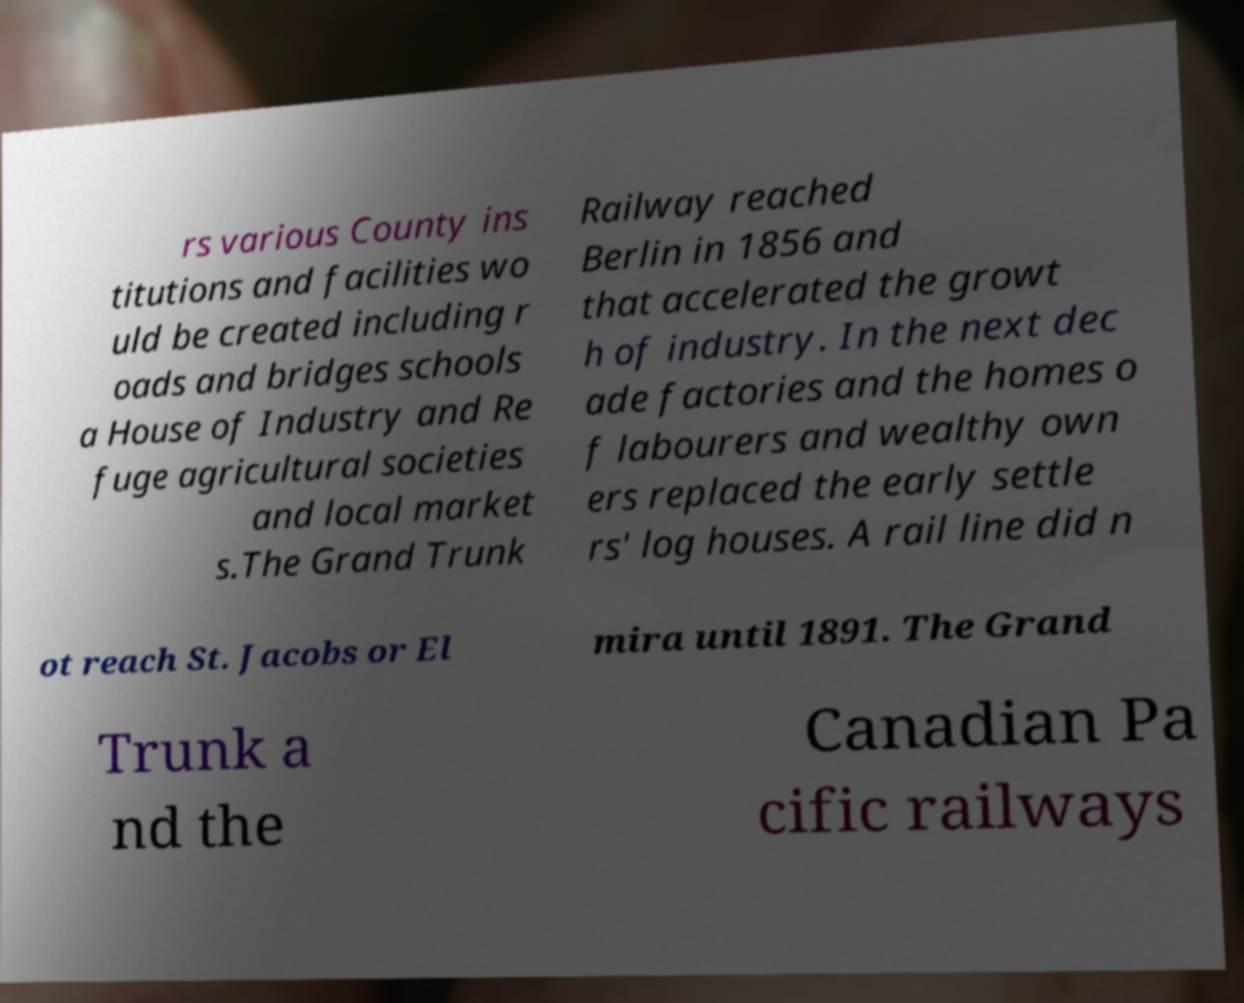There's text embedded in this image that I need extracted. Can you transcribe it verbatim? rs various County ins titutions and facilities wo uld be created including r oads and bridges schools a House of Industry and Re fuge agricultural societies and local market s.The Grand Trunk Railway reached Berlin in 1856 and that accelerated the growt h of industry. In the next dec ade factories and the homes o f labourers and wealthy own ers replaced the early settle rs' log houses. A rail line did n ot reach St. Jacobs or El mira until 1891. The Grand Trunk a nd the Canadian Pa cific railways 